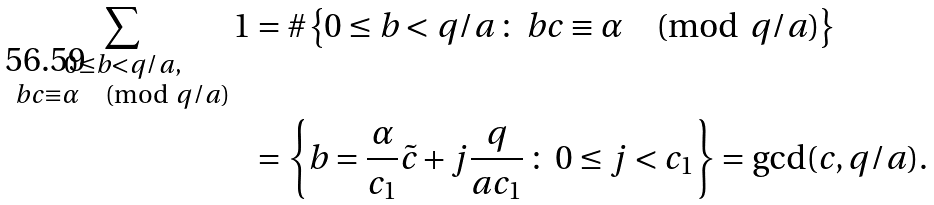<formula> <loc_0><loc_0><loc_500><loc_500>\sum _ { \substack { 0 \leq b < q / a , \\ b c \equiv \alpha \pmod { q / a } } } 1 & = \# \left \{ 0 \leq b < q / a \, \colon \, b c \equiv \alpha \pmod { q / a } \right \} \\ & = \left \{ b = \frac { \alpha } { c _ { 1 } } \tilde { c } + j \frac { q } { a c _ { 1 } } \, \colon \, 0 \leq j < c _ { 1 } \right \} = \gcd ( c , q / a ) .</formula> 